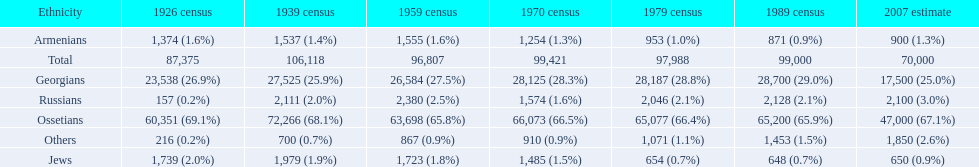Which population had the most people in 1926? Ossetians. Give me the full table as a dictionary. {'header': ['Ethnicity', '1926 census', '1939 census', '1959 census', '1970 census', '1979 census', '1989 census', '2007 estimate'], 'rows': [['Armenians', '1,374 (1.6%)', '1,537 (1.4%)', '1,555 (1.6%)', '1,254 (1.3%)', '953 (1.0%)', '871 (0.9%)', '900 (1.3%)'], ['Total', '87,375', '106,118', '96,807', '99,421', '97,988', '99,000', '70,000'], ['Georgians', '23,538 (26.9%)', '27,525 (25.9%)', '26,584 (27.5%)', '28,125 (28.3%)', '28,187 (28.8%)', '28,700 (29.0%)', '17,500 (25.0%)'], ['Russians', '157 (0.2%)', '2,111 (2.0%)', '2,380 (2.5%)', '1,574 (1.6%)', '2,046 (2.1%)', '2,128 (2.1%)', '2,100 (3.0%)'], ['Ossetians', '60,351 (69.1%)', '72,266 (68.1%)', '63,698 (65.8%)', '66,073 (66.5%)', '65,077 (66.4%)', '65,200 (65.9%)', '47,000 (67.1%)'], ['Others', '216 (0.2%)', '700 (0.7%)', '867 (0.9%)', '910 (0.9%)', '1,071 (1.1%)', '1,453 (1.5%)', '1,850 (2.6%)'], ['Jews', '1,739 (2.0%)', '1,979 (1.9%)', '1,723 (1.8%)', '1,485 (1.5%)', '654 (0.7%)', '648 (0.7%)', '650 (0.9%)']]} 